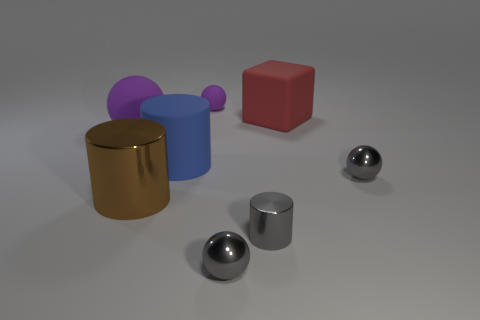What material is the sphere that is the same size as the blue matte object?
Make the answer very short. Rubber. What is the size of the rubber thing to the right of the tiny gray sphere that is on the left side of the small metallic object behind the big brown cylinder?
Your response must be concise. Large. There is a cube that is made of the same material as the big purple object; what is its size?
Make the answer very short. Large. There is a brown shiny cylinder; is it the same size as the rubber object that is on the left side of the blue matte thing?
Provide a succinct answer. Yes. What is the shape of the big rubber object to the right of the small purple object?
Keep it short and to the point. Cube. Are there any purple balls in front of the object to the right of the big matte thing that is on the right side of the blue matte thing?
Your answer should be compact. No. There is a large object that is the same shape as the small matte object; what material is it?
Make the answer very short. Rubber. Are there any other things that are the same material as the blue cylinder?
Offer a terse response. Yes. How many balls are either brown things or tiny purple matte objects?
Your answer should be compact. 1. There is a purple rubber object to the right of the blue object; is it the same size as the block that is behind the big brown metallic object?
Your answer should be very brief. No. 